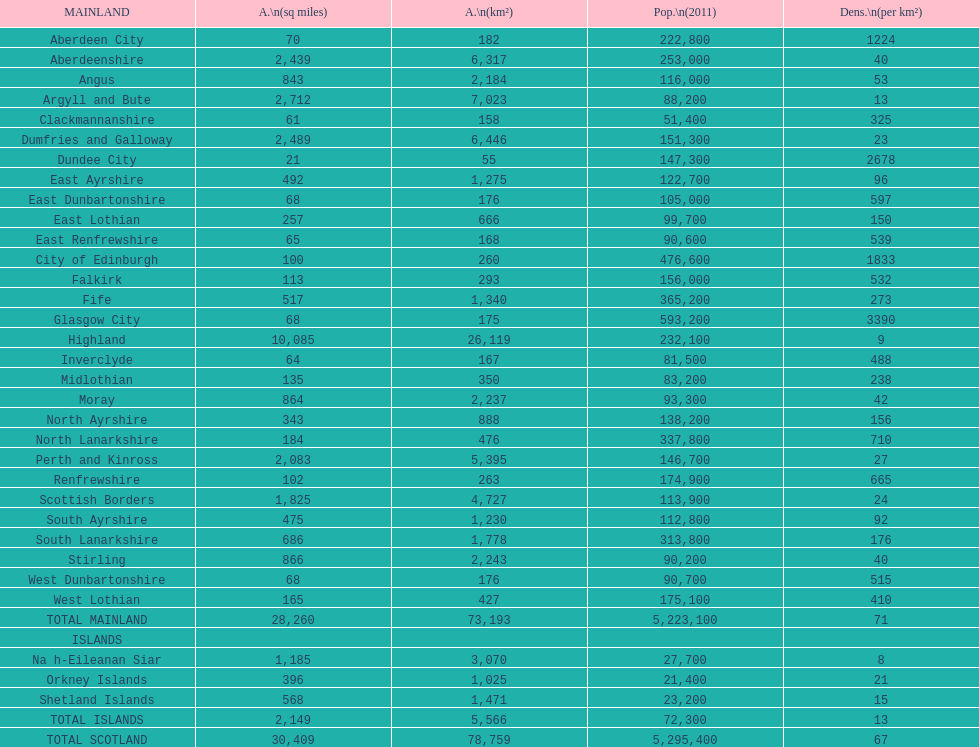What is the number of people living in angus in 2011? 116,000. 